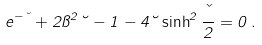<formula> <loc_0><loc_0><loc_500><loc_500>e ^ { - \kappa } + 2 \pi ^ { 2 } \lambda - 1 - 4 \lambda \sinh ^ { 2 } \frac { \kappa } { 2 } = 0 \, .</formula> 